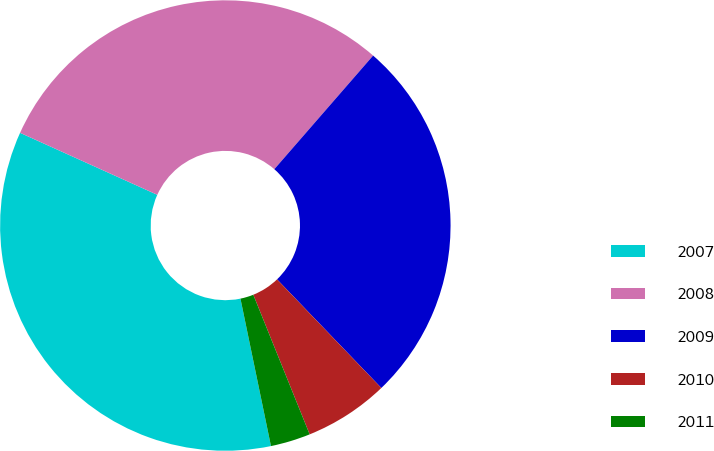Convert chart to OTSL. <chart><loc_0><loc_0><loc_500><loc_500><pie_chart><fcel>2007<fcel>2008<fcel>2009<fcel>2010<fcel>2011<nl><fcel>35.0%<fcel>29.64%<fcel>26.43%<fcel>6.07%<fcel>2.86%<nl></chart> 